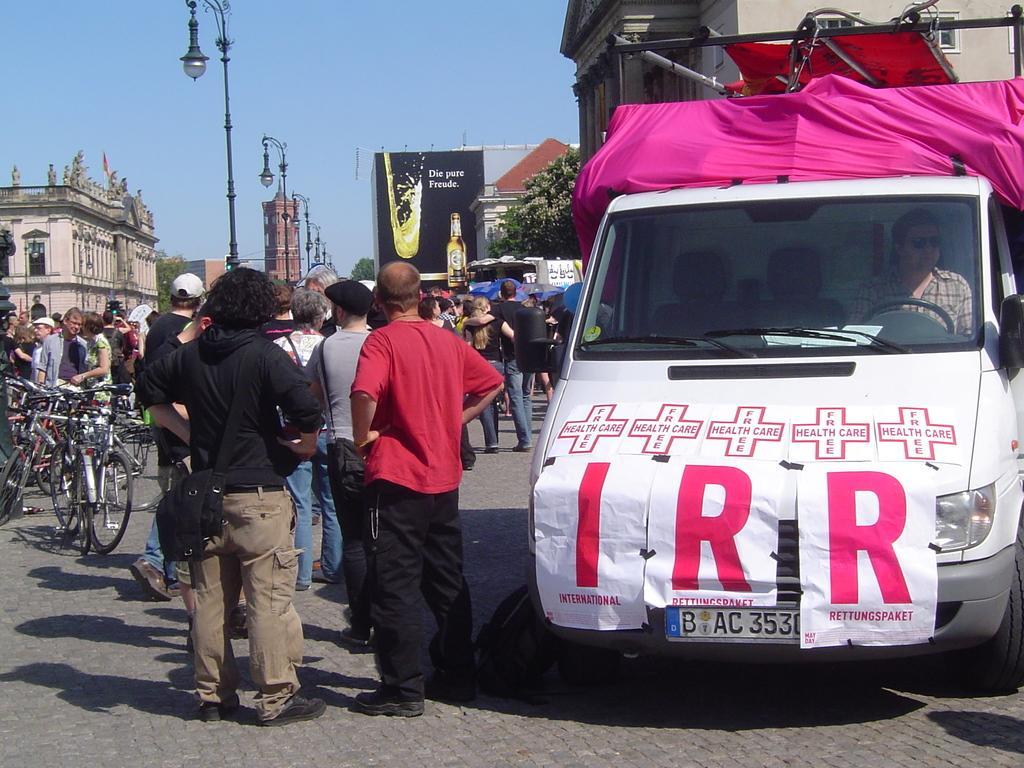In one or two sentences, can you explain what this image depicts? As we can see in the image, there are few people standing here and there. On the left there are bicycles, a building and there are street lamps. On the right there is a car and a poster is attached to the car. In the background there is a banner and tree. 